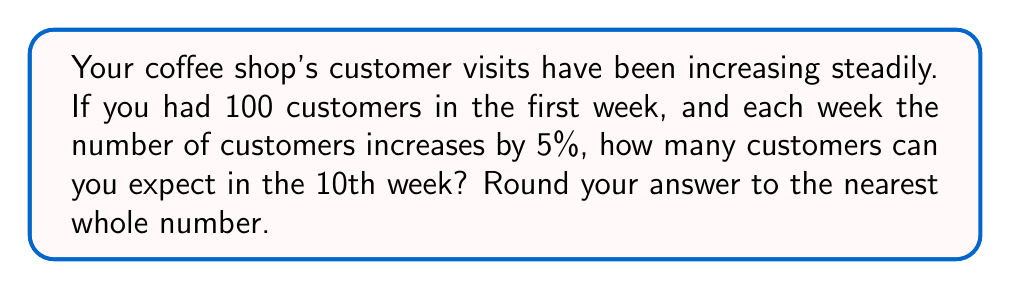Could you help me with this problem? To solve this problem, we'll use the formula for the nth term of a geometric sequence:

$$a_n = a_1 \cdot r^{n-1}$$

Where:
$a_n$ is the number of customers in the nth week
$a_1$ is the initial number of customers (100)
$r$ is the common ratio (1.05, because it's a 5% increase)
$n$ is the week number (10)

Let's substitute these values:

$$a_{10} = 100 \cdot (1.05)^{10-1}$$

$$a_{10} = 100 \cdot (1.05)^9$$

Now, let's calculate:

$$a_{10} = 100 \cdot 1.551328$$

$$a_{10} = 155.1328$$

Rounding to the nearest whole number:

$$a_{10} \approx 155$$
Answer: 155 customers 